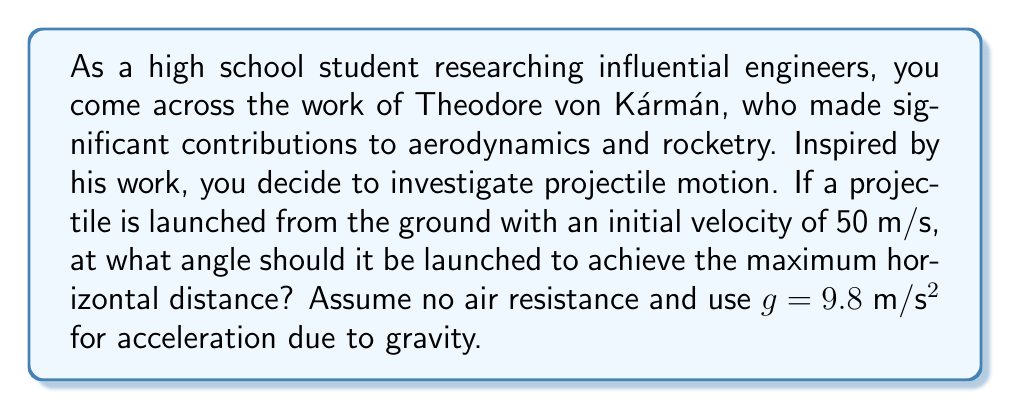Can you answer this question? To solve this problem, we'll use concepts from trigonometry and physics:

1) The range (R) of a projectile launched from ground level is given by the equation:

   $$R = \frac{v_0^2 \sin(2\theta)}{g}$$

   Where $v_0$ is the initial velocity, $\theta$ is the launch angle, and $g$ is the acceleration due to gravity.

2) To find the maximum range, we need to maximize $\sin(2\theta)$. The sine function reaches its maximum value of 1 when its argument is 90°.

3) Therefore, for maximum range:

   $$2\theta = 90°$$
   $$\theta = 45°$$

4) We can verify this mathematically by differentiating the range equation with respect to $\theta$ and setting it to zero:

   $$\frac{dR}{d\theta} = \frac{v_0^2}{g} \cdot 2\cos(2\theta) = 0$$

   This is true when $\cos(2\theta) = 0$, which occurs when $2\theta = 90°$ or $\theta = 45°$.

5) This result is independent of the initial velocity and acceleration due to gravity, making it a universal principle in projectile motion without air resistance.

[asy]
import geometry;

size(200);
pair O=(0,0), A=(100,100), B=(200,0);
draw(O--A--B);
draw(O--B);
label("45°", (20,20), SE);
label("Ground", (100,-10), N);
draw(arc(O,20,0,45), Arrow);
[/asy]

This principle has been crucial in the development of ballistics and rocketry, fields where von Kármán made significant contributions.
Answer: The optimal angle for maximum projectile distance is $45°$. 